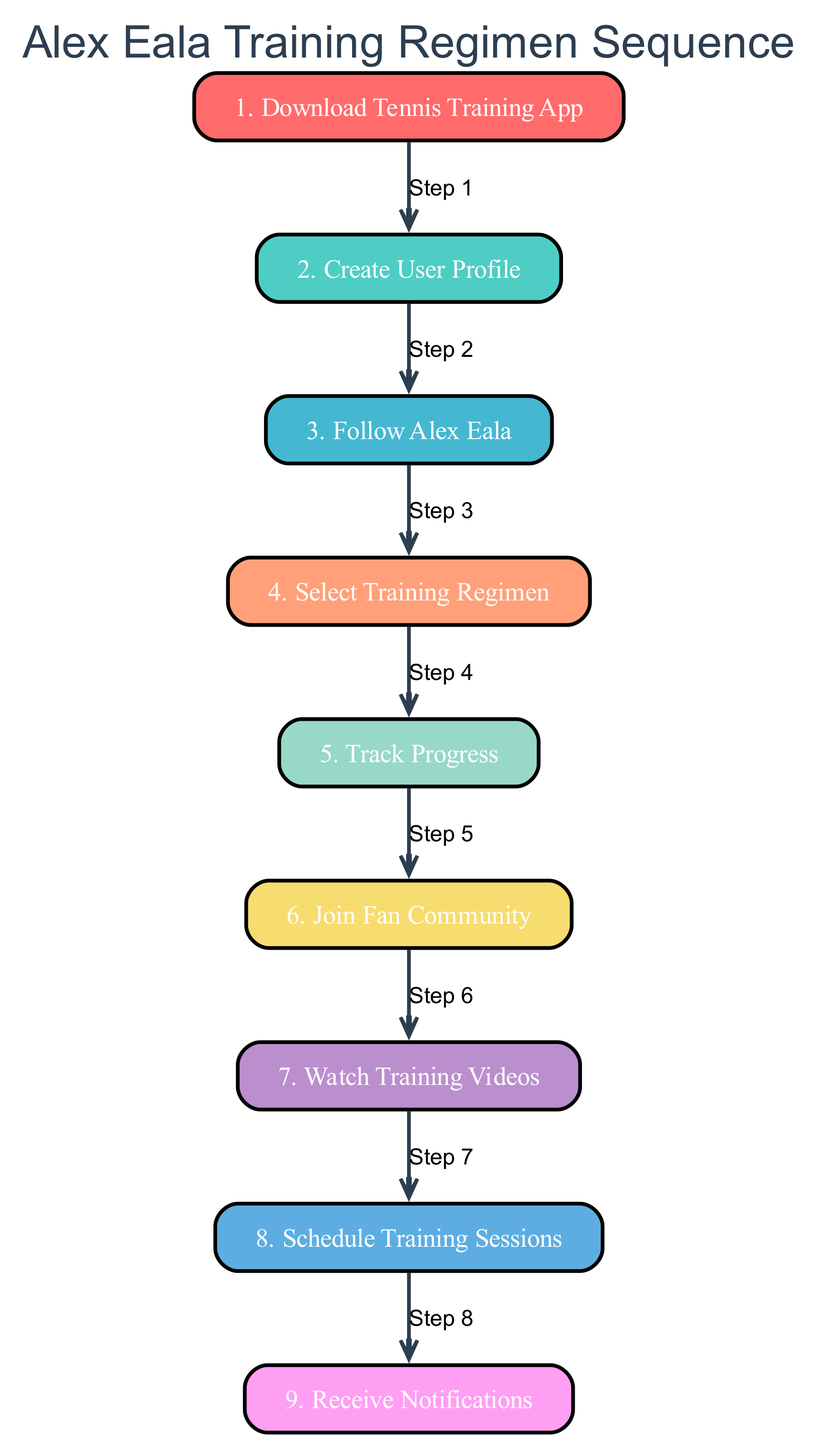What is the total number of steps in the training regimen? The diagram contains a series of steps connected in sequence. By counting these steps, I find there are 9 in total, as represented by the labeled nodes in the diagram.
Answer: 9 Which step comes directly after "Create User Profile"? Looking at the diagram, after "Create User Profile," the immediate next step is "Follow Alex Eala." This is the direct connection indicated by the arrow pointing from "Create User Profile" to "Follow Alex Eala."
Answer: Follow Alex Eala What color is the node for "Track Progress"? Referring to the diagram, the color of "Track Progress" is determined by its positioning in the sequence. It is the fifth step, and based on the defined color scheme, the color assigned to this step is '#F7DC6F.'
Answer: #F7DC6F How many steps involve watching or tracking content related to Alex Eala? By examining the diagram, I notice that there are two specific steps dedicated to watching or tracking content: "Watch Training Videos" and "Track Progress." I count these instances to find there are a total of 2 such steps.
Answer: 2 What step precedes "Schedule Training Sessions"? The analysis of the diagram shows that "Watch Training Videos" is directly linked to "Schedule Training Sessions," leading into it according to the sequence of the steps. Thus, "Watch Training Videos" comes before it.
Answer: Watch Training Videos What is the last step in the sequence? Looking at the progression of the steps in the diagram, the last node that is reached in the sequence is "Receive Notifications," which indicates the end of the training regimen steps.
Answer: Receive Notifications What is the purpose of the "Join Fan Community" step? By interpreting the description associated with "Join Fan Community," its purpose is to engage with other fans and athletes in the app's community section, providing a means for support and tips.
Answer: Engage with other fans Which step involves selecting a training program? Referring back to the diagram's flow, "Select Training Regimen" is specifically the step that mentions choosing a training program based on Alex Eala's regimen. This is clearly identifiable within the listed steps.
Answer: Select Training Regimen What action should be taken immediately after "Track Progress"? The sequence indicates that right after "Track Progress," the next action to undertake is to "Join Fan Community." This correspondence reflects the flow as designed in the diagram.
Answer: Join Fan Community 